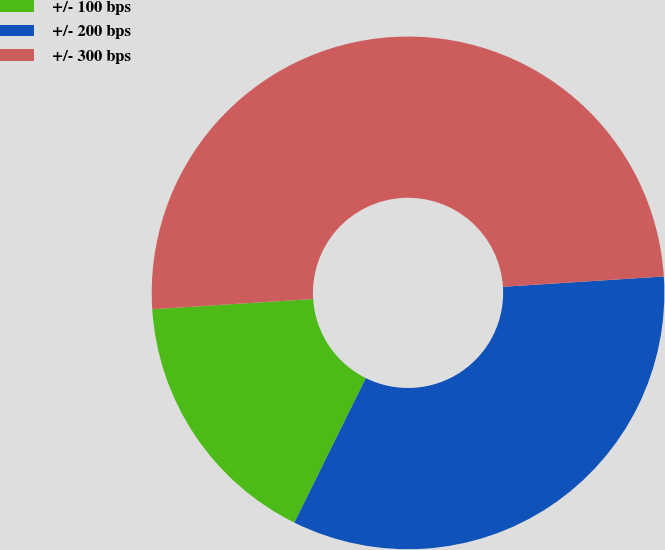Convert chart to OTSL. <chart><loc_0><loc_0><loc_500><loc_500><pie_chart><fcel>+/- 100 bps<fcel>+/- 200 bps<fcel>+/- 300 bps<nl><fcel>16.67%<fcel>33.33%<fcel>50.0%<nl></chart> 